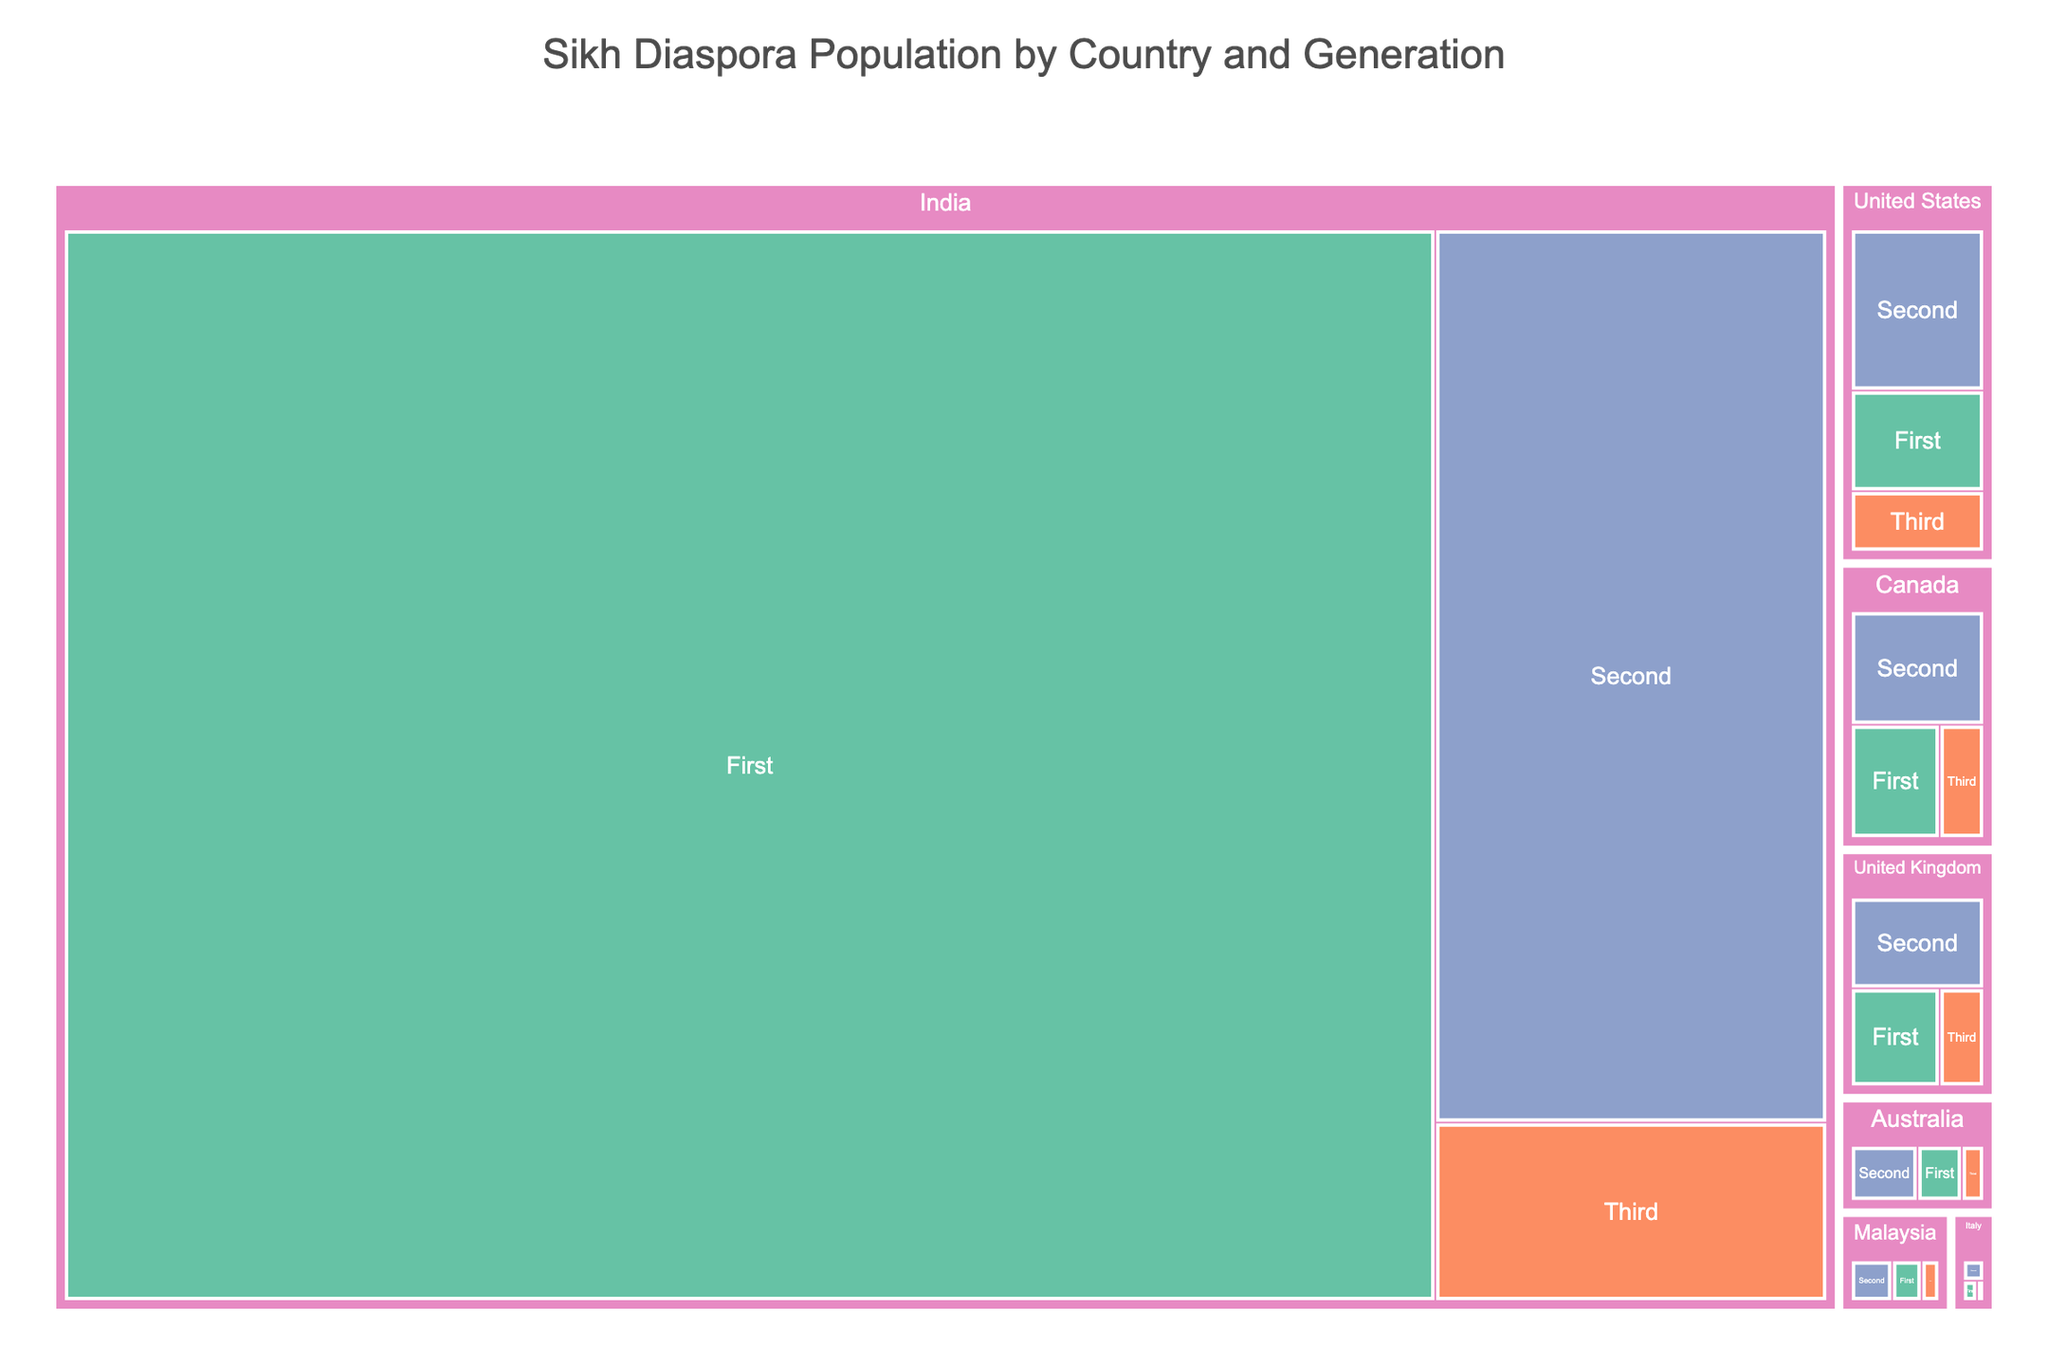What is the title of the Treemap? The title of the Treemap is prominently displayed at the top of the figure. It provides the main idea or theme the figure represents.
Answer: Sikh Diaspora Population by Country and Generation Which country has the largest Sikh population? By observing the treemap, the country with the largest area or section represents the country with the largest population.
Answer: India How many generations are depicted for each country in the figure? Every country section is further divided into three smaller sections, indicating the three generation categories depicted for each country.
Answer: Three (First, Second, Third) Which has a higher Sikh second-generation population, Canada or the United Kingdom? By comparing the relative sizes of the sections labeled "Second" under Canada and the United Kingdom, we can determine which is larger.
Answer: Canada How does the Sikh third-generation population in Australia compare to its first-generation population? Compare the section sizes labeled "Third" and "First" under Australia to determine which one is larger.
Answer: The first-generation population is larger Among Malaysia, Italy, and Australia, which country has the smallest total Sikh population? By comparing the overall sizes of the sections for Malaysia, Italy, and Australia, we can see which one is the smallest.
Answer: Italy What is the total Sikh population in the United States according to the figure? Sum the populations of first, second, and third-generation Sikhs in the US as shown in the figure.
Answer: 800,000 (250,000 + 400,000 + 150,000) Compare the first-generation Sikh populations in the United Kingdom and Canada. Which is larger? Simply compare the sizes of the "First" sections under the United Kingdom and Canada.
Answer: United Kingdom What is the combined Sikh population of the second and third generation in Malaysia? Add the populations of the second and third-generation Sikhs in Malaysia.
Answer: 100,000 (70,000 + 30,000) If you sum the Sikh populations of the first generation in the United States and Canada, what is the result? Add the first-generation Sikh populations in the United States and Canada.
Answer: 450,000 (250,000 + 200,000) 